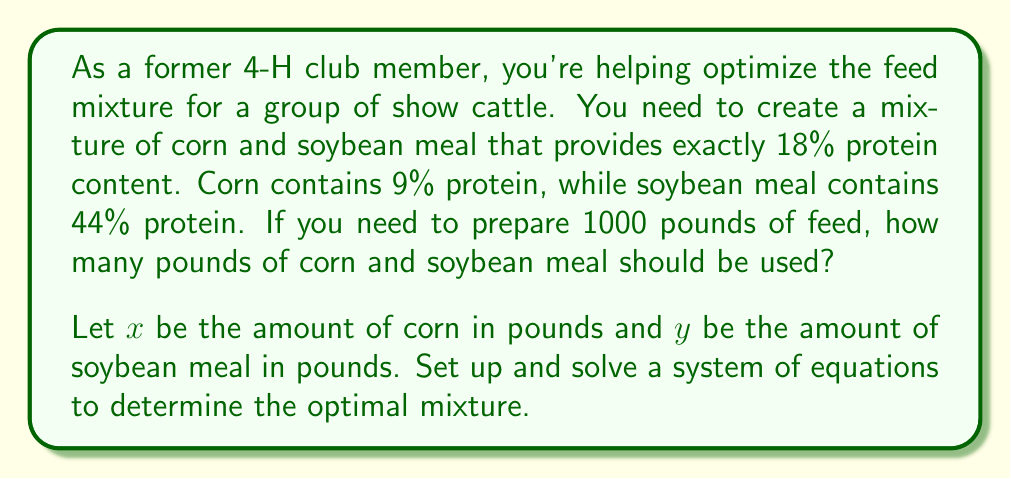Show me your answer to this math problem. Let's approach this step-by-step:

1) First, we need to set up two equations based on the given information:

   Equation 1: The total amount of feed should be 1000 pounds
   $$ x + y = 1000 $$

   Equation 2: The protein content should be 18% of the total feed
   $$ 0.09x + 0.44y = 0.18(1000) = 180 $$

2) Now we have a system of two equations with two unknowns:
   $$ \begin{cases}
   x + y = 1000 \\
   0.09x + 0.44y = 180
   \end{cases} $$

3) Let's solve this system by substitution. From the first equation:
   $$ y = 1000 - x $$

4) Substitute this into the second equation:
   $$ 0.09x + 0.44(1000 - x) = 180 $$

5) Simplify:
   $$ 0.09x + 440 - 0.44x = 180 $$
   $$ 440 - 0.35x = 180 $$

6) Subtract 440 from both sides:
   $$ -0.35x = -260 $$

7) Divide both sides by -0.35:
   $$ x = 742.86 $$

8) Round to the nearest whole number (since we can't have partial pounds of feed):
   $$ x = 743 \text{ pounds of corn} $$

9) Substitute this back into the equation from step 3 to find y:
   $$ y = 1000 - 743 = 257 \text{ pounds of soybean meal} $$

Therefore, the optimal mixture is 743 pounds of corn and 257 pounds of soybean meal.
Answer: 743 lbs corn, 257 lbs soybean meal 